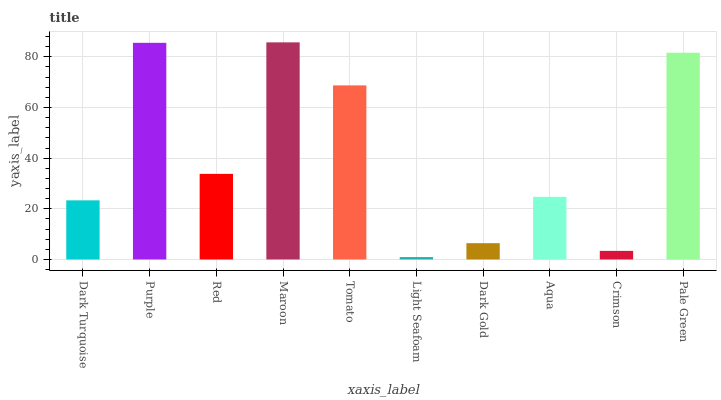Is Light Seafoam the minimum?
Answer yes or no. Yes. Is Maroon the maximum?
Answer yes or no. Yes. Is Purple the minimum?
Answer yes or no. No. Is Purple the maximum?
Answer yes or no. No. Is Purple greater than Dark Turquoise?
Answer yes or no. Yes. Is Dark Turquoise less than Purple?
Answer yes or no. Yes. Is Dark Turquoise greater than Purple?
Answer yes or no. No. Is Purple less than Dark Turquoise?
Answer yes or no. No. Is Red the high median?
Answer yes or no. Yes. Is Aqua the low median?
Answer yes or no. Yes. Is Aqua the high median?
Answer yes or no. No. Is Crimson the low median?
Answer yes or no. No. 